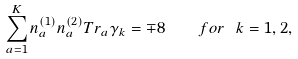<formula> <loc_0><loc_0><loc_500><loc_500>\sum _ { a = 1 } ^ { K } n _ { a } ^ { ( 1 ) } n _ { a } ^ { ( 2 ) } T r _ { a } \gamma _ { k } = \mp 8 \quad f o r \ k = 1 , 2 ,</formula> 